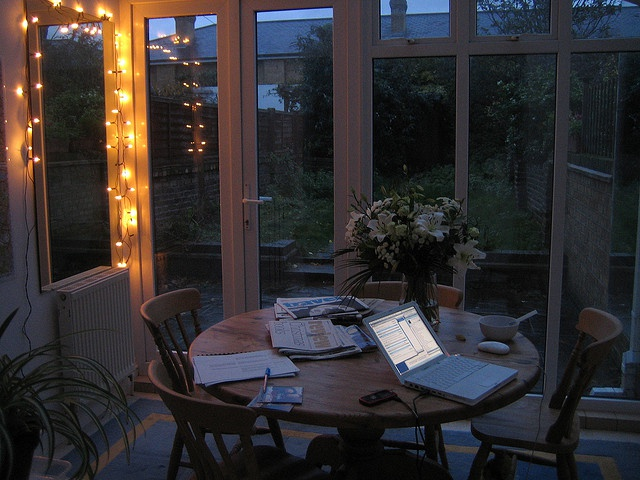Describe the objects in this image and their specific colors. I can see dining table in brown, black, and gray tones, potted plant in brown and black tones, potted plant in brown, black, and gray tones, chair in brown, black, gray, and darkblue tones, and chair in brown and black tones in this image. 